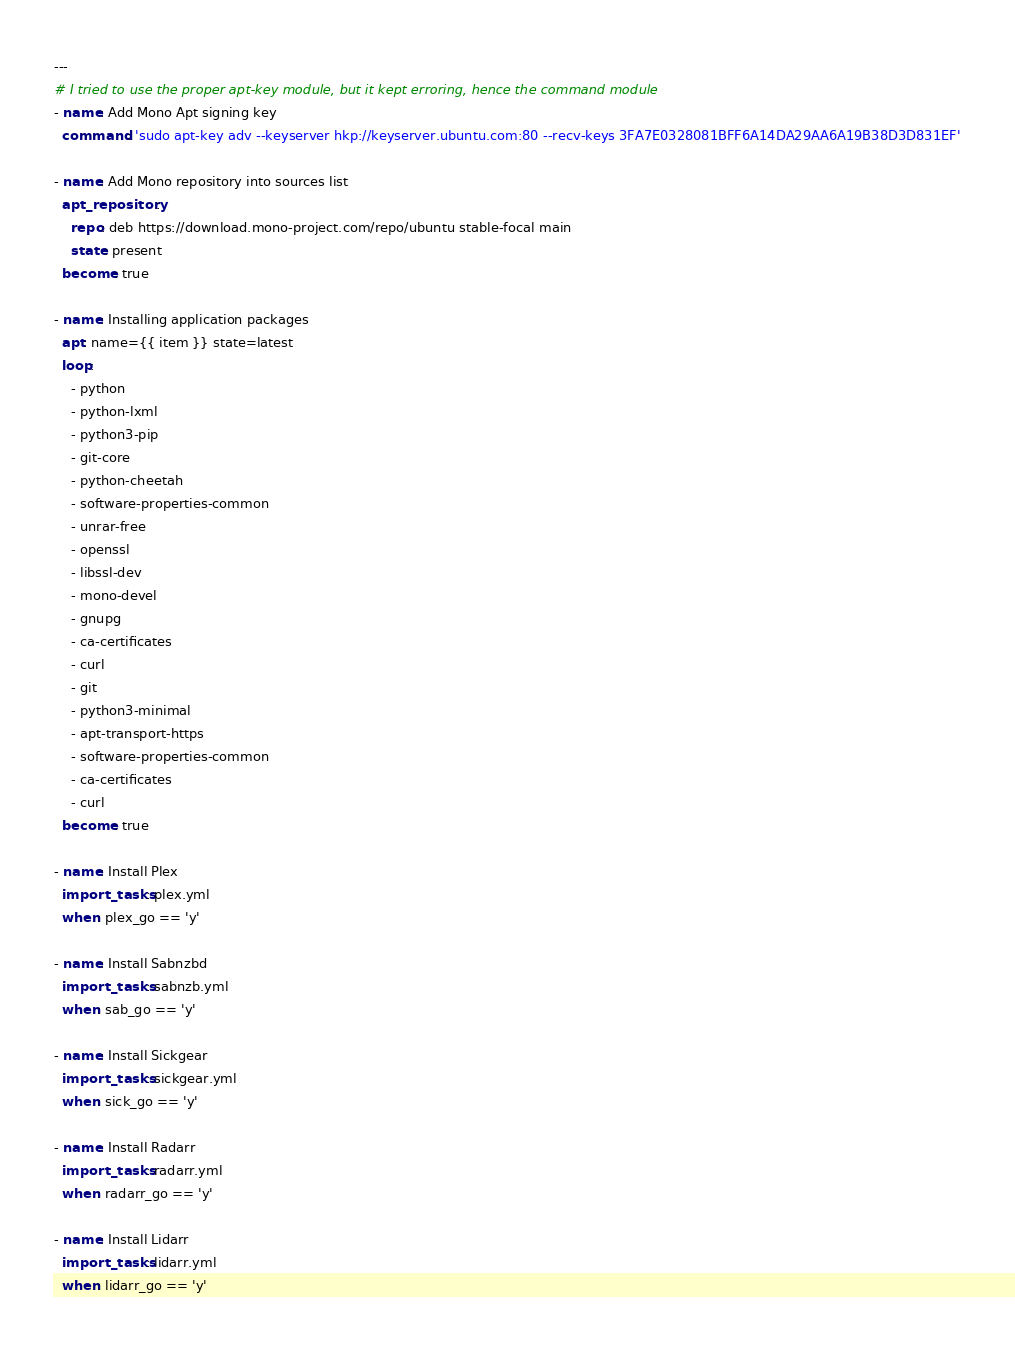<code> <loc_0><loc_0><loc_500><loc_500><_YAML_>---
# I tried to use the proper apt-key module, but it kept erroring, hence the command module
- name: Add Mono Apt signing key
  command: 'sudo apt-key adv --keyserver hkp://keyserver.ubuntu.com:80 --recv-keys 3FA7E0328081BFF6A14DA29AA6A19B38D3D831EF'

- name: Add Mono repository into sources list
  apt_repository:
    repo: deb https://download.mono-project.com/repo/ubuntu stable-focal main
    state: present
  become: true

- name: Installing application packages
  apt: name={{ item }} state=latest
  loop:
    - python
    - python-lxml
    - python3-pip
    - git-core
    - python-cheetah
    - software-properties-common
    - unrar-free
    - openssl
    - libssl-dev
    - mono-devel
    - gnupg
    - ca-certificates
    - curl
    - git
    - python3-minimal
    - apt-transport-https
    - software-properties-common
    - ca-certificates
    - curl
  become: true

- name: Install Plex
  import_tasks: plex.yml
  when: plex_go == 'y'

- name: Install Sabnzbd
  import_tasks: sabnzb.yml
  when: sab_go == 'y'

- name: Install Sickgear
  import_tasks: sickgear.yml
  when: sick_go == 'y'

- name: Install Radarr
  import_tasks: radarr.yml
  when: radarr_go == 'y'

- name: Install Lidarr
  import_tasks: lidarr.yml
  when: lidarr_go == 'y'
</code> 